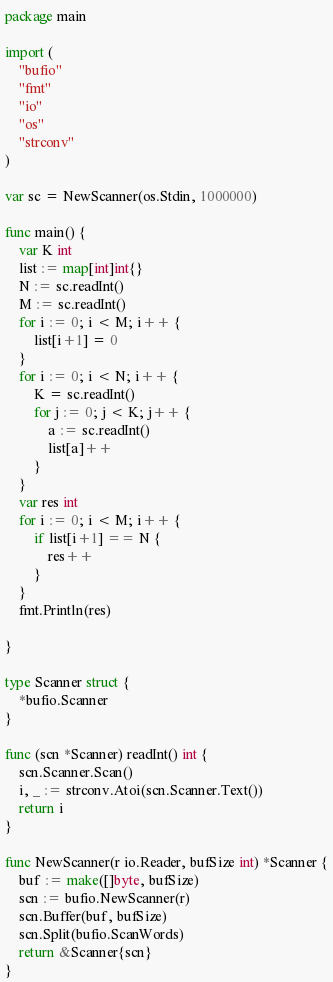Convert code to text. <code><loc_0><loc_0><loc_500><loc_500><_Go_>package main

import (
	"bufio"
	"fmt"
	"io"
	"os"
	"strconv"
)

var sc = NewScanner(os.Stdin, 1000000)

func main() {
	var K int
	list := map[int]int{}
	N := sc.readInt()
	M := sc.readInt()
	for i := 0; i < M; i++ {
		list[i+1] = 0
	}
	for i := 0; i < N; i++ {
		K = sc.readInt()
		for j := 0; j < K; j++ {
			a := sc.readInt()
			list[a]++
		}
	}
	var res int
	for i := 0; i < M; i++ {
		if list[i+1] == N {
			res++
		}
	}
	fmt.Println(res)

}

type Scanner struct {
	*bufio.Scanner
}

func (scn *Scanner) readInt() int {
	scn.Scanner.Scan()
	i, _ := strconv.Atoi(scn.Scanner.Text())
	return i
}

func NewScanner(r io.Reader, bufSize int) *Scanner {
	buf := make([]byte, bufSize)
	scn := bufio.NewScanner(r)
	scn.Buffer(buf, bufSize)
	scn.Split(bufio.ScanWords)
	return &Scanner{scn}
}
</code> 